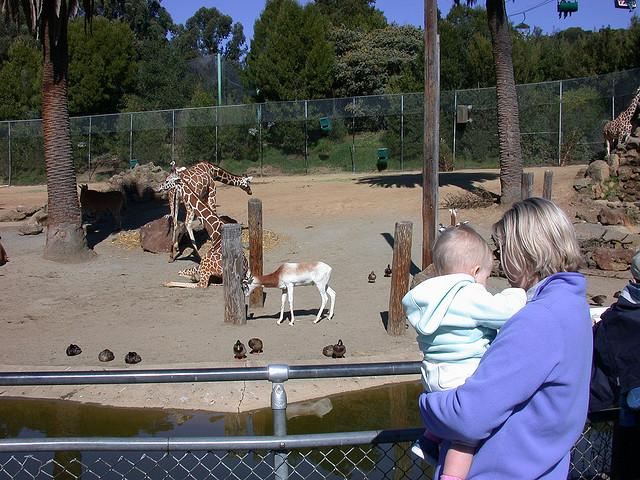Which animal is this?
Keep it brief. Giraffe. What color is her shirt?
Short answer required. Purple. Is this a zoo?
Keep it brief. Yes. What is she doing?
Answer briefly. Holding baby. What animal is this?
Give a very brief answer. Giraffe. What color is the plastic container inside the cage?
Be succinct. Brown. What relationship do you think this is?
Concise answer only. Mother/child. Does the person work at the zoo?
Give a very brief answer. No. What animal is in the picture?
Answer briefly. Giraffe. What is the woman holding in her hands?
Answer briefly. Baby. Is the baby petting the giraffe?
Keep it brief. No. Are all the giraffe standing?
Answer briefly. No. 